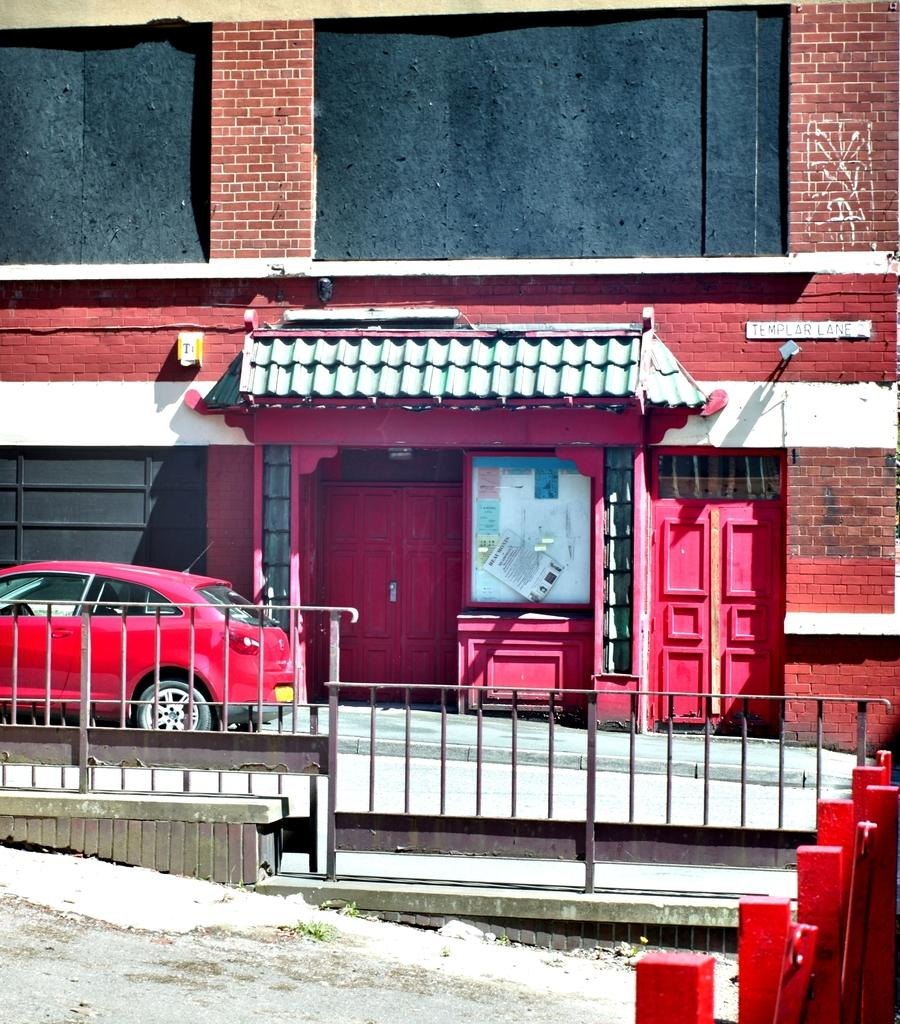What type of structure is present in the image? There is a building in the image. What features can be seen on the building? The building has doors and boards. What is located in front of the building? There is a fence in front of the building. What else can be seen on the ground in the image? There is a car on the ground in the image. How does the tramp perform tricks on the building in the image? There is no tramp performing tricks in the image; the image only features a building, doors, boards, a fence, and a car. 